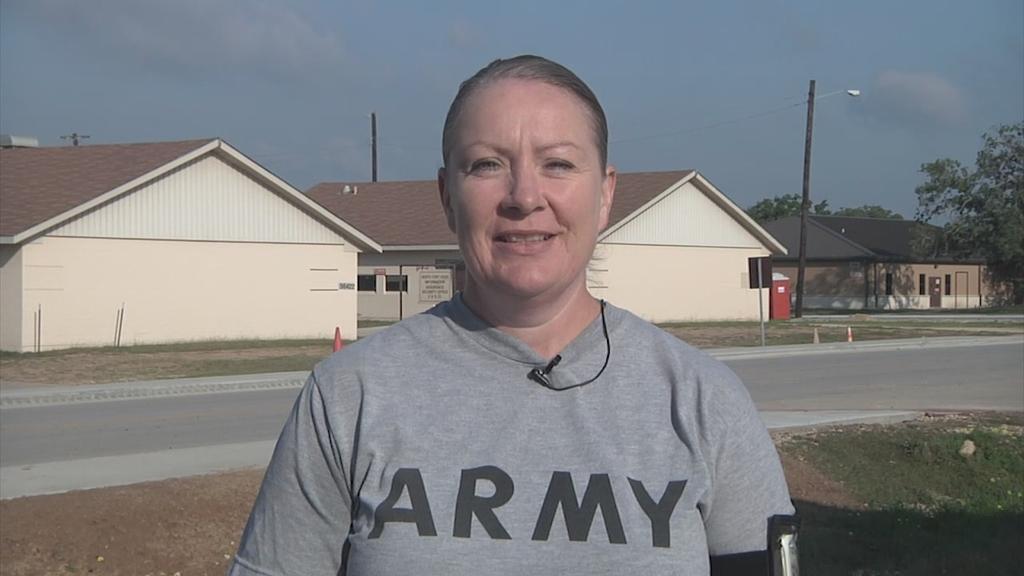Can you describe this image briefly? In this image there is a person smiling, and in the background there is road, cone bar barricades, houses,trees, sky. 